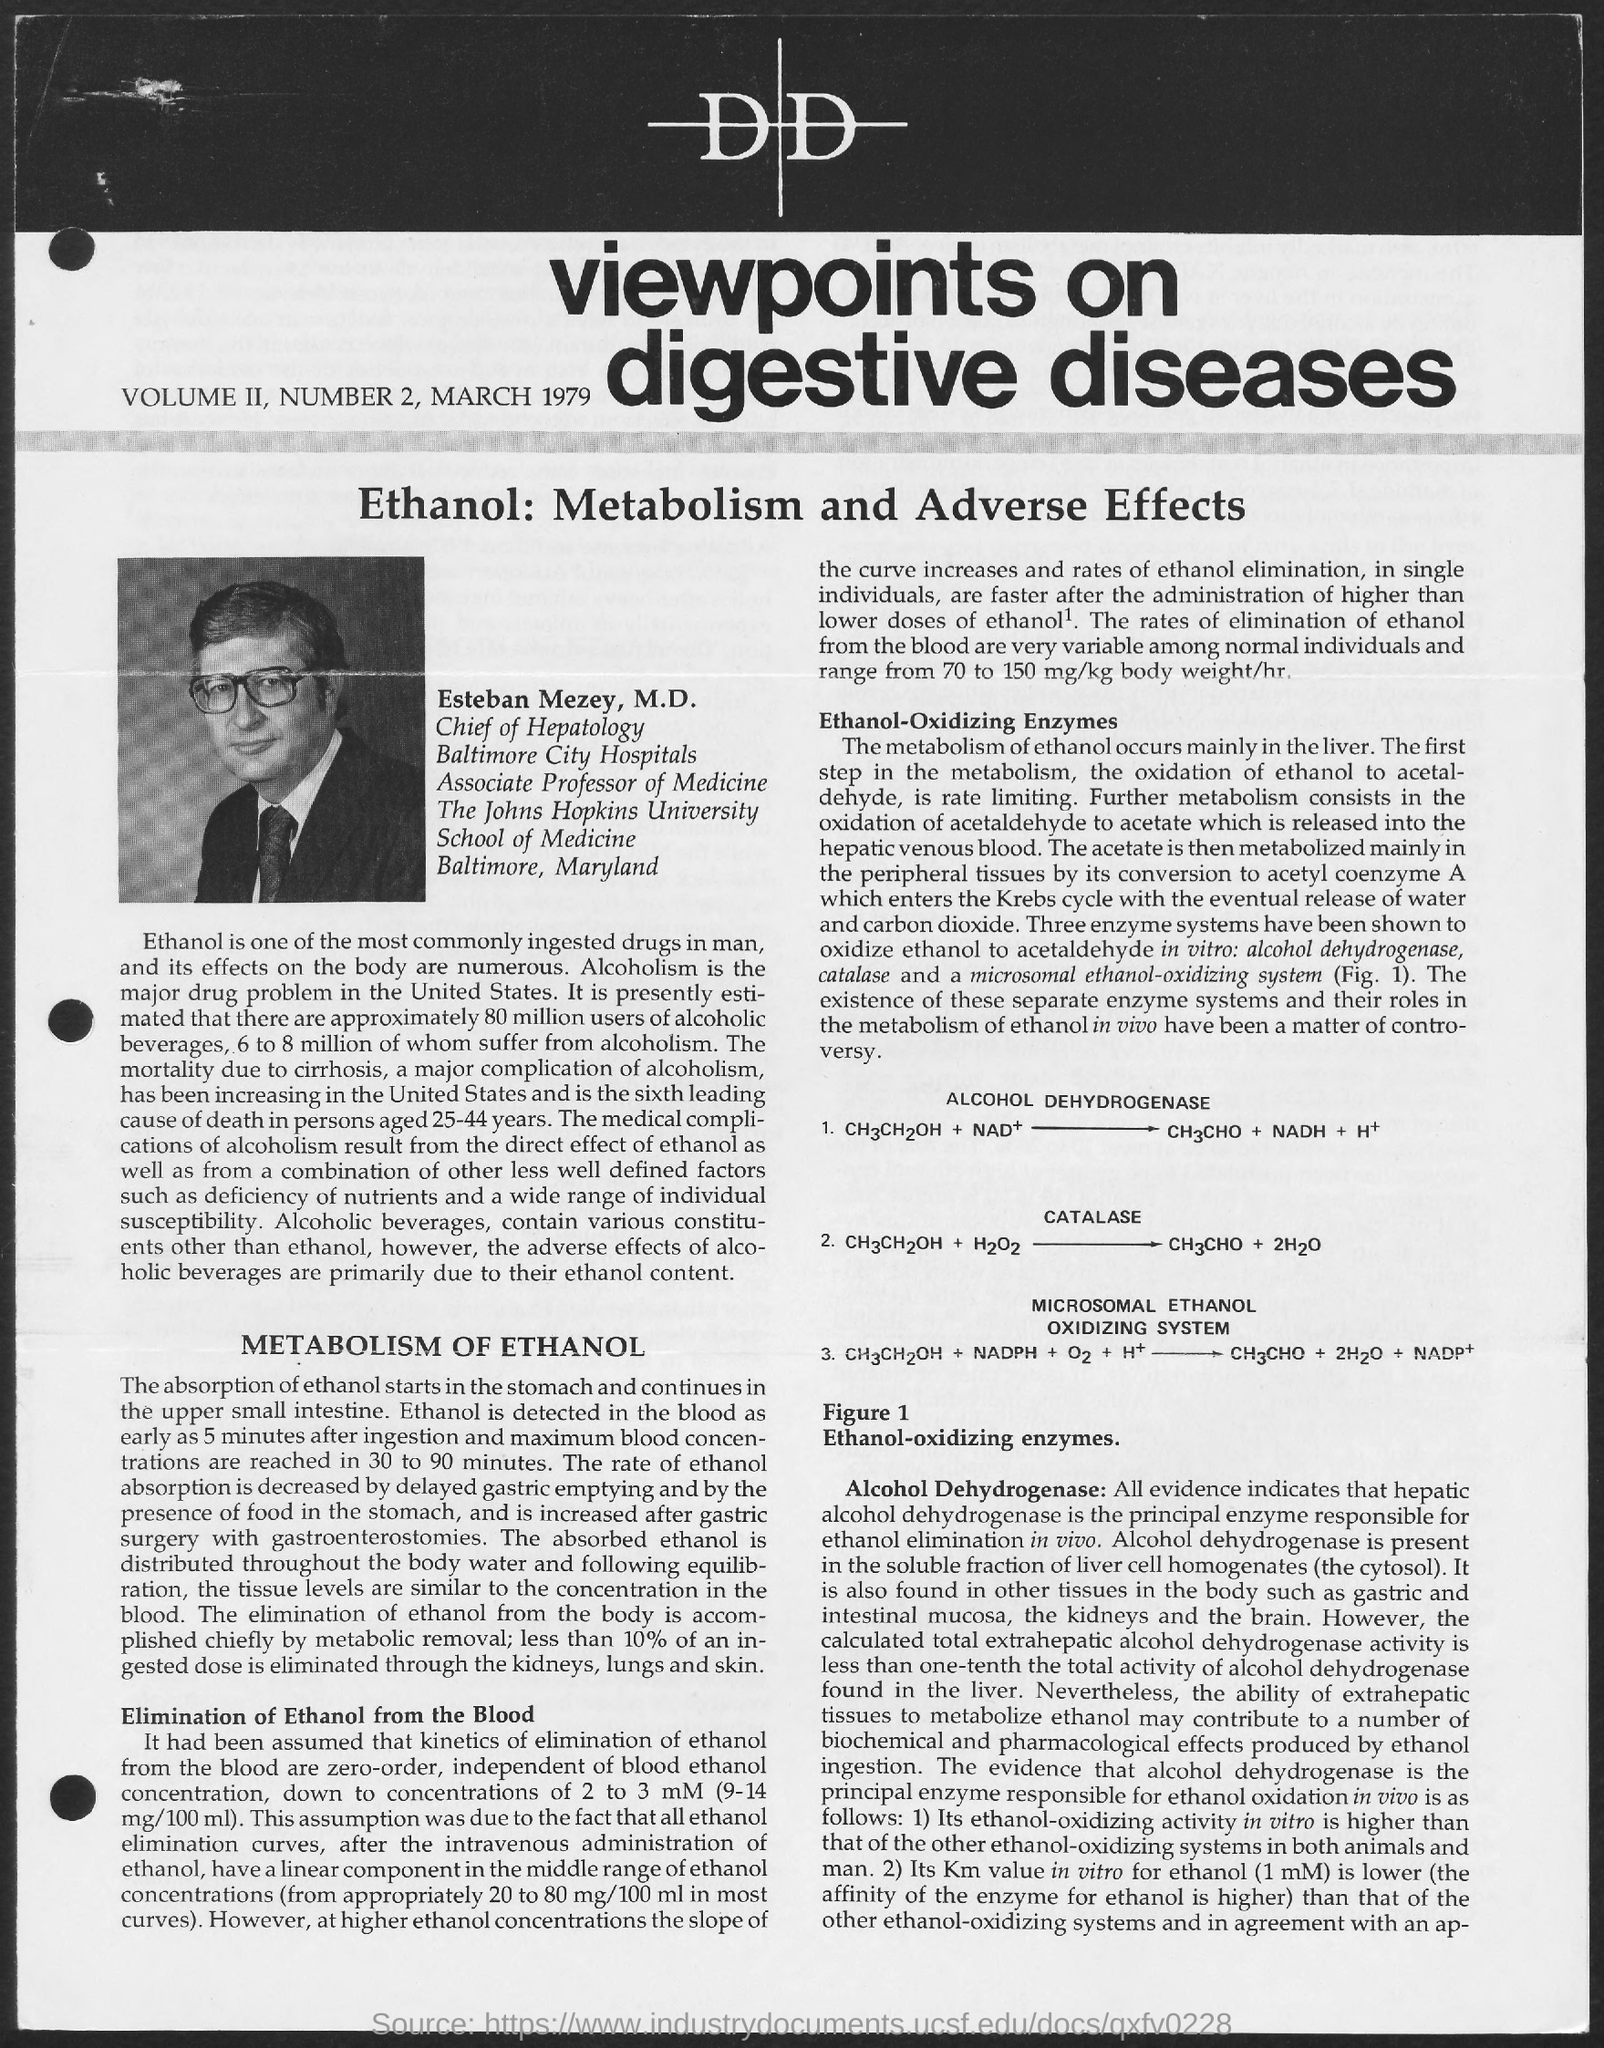What is the date on the document?
Give a very brief answer. March 1979. 